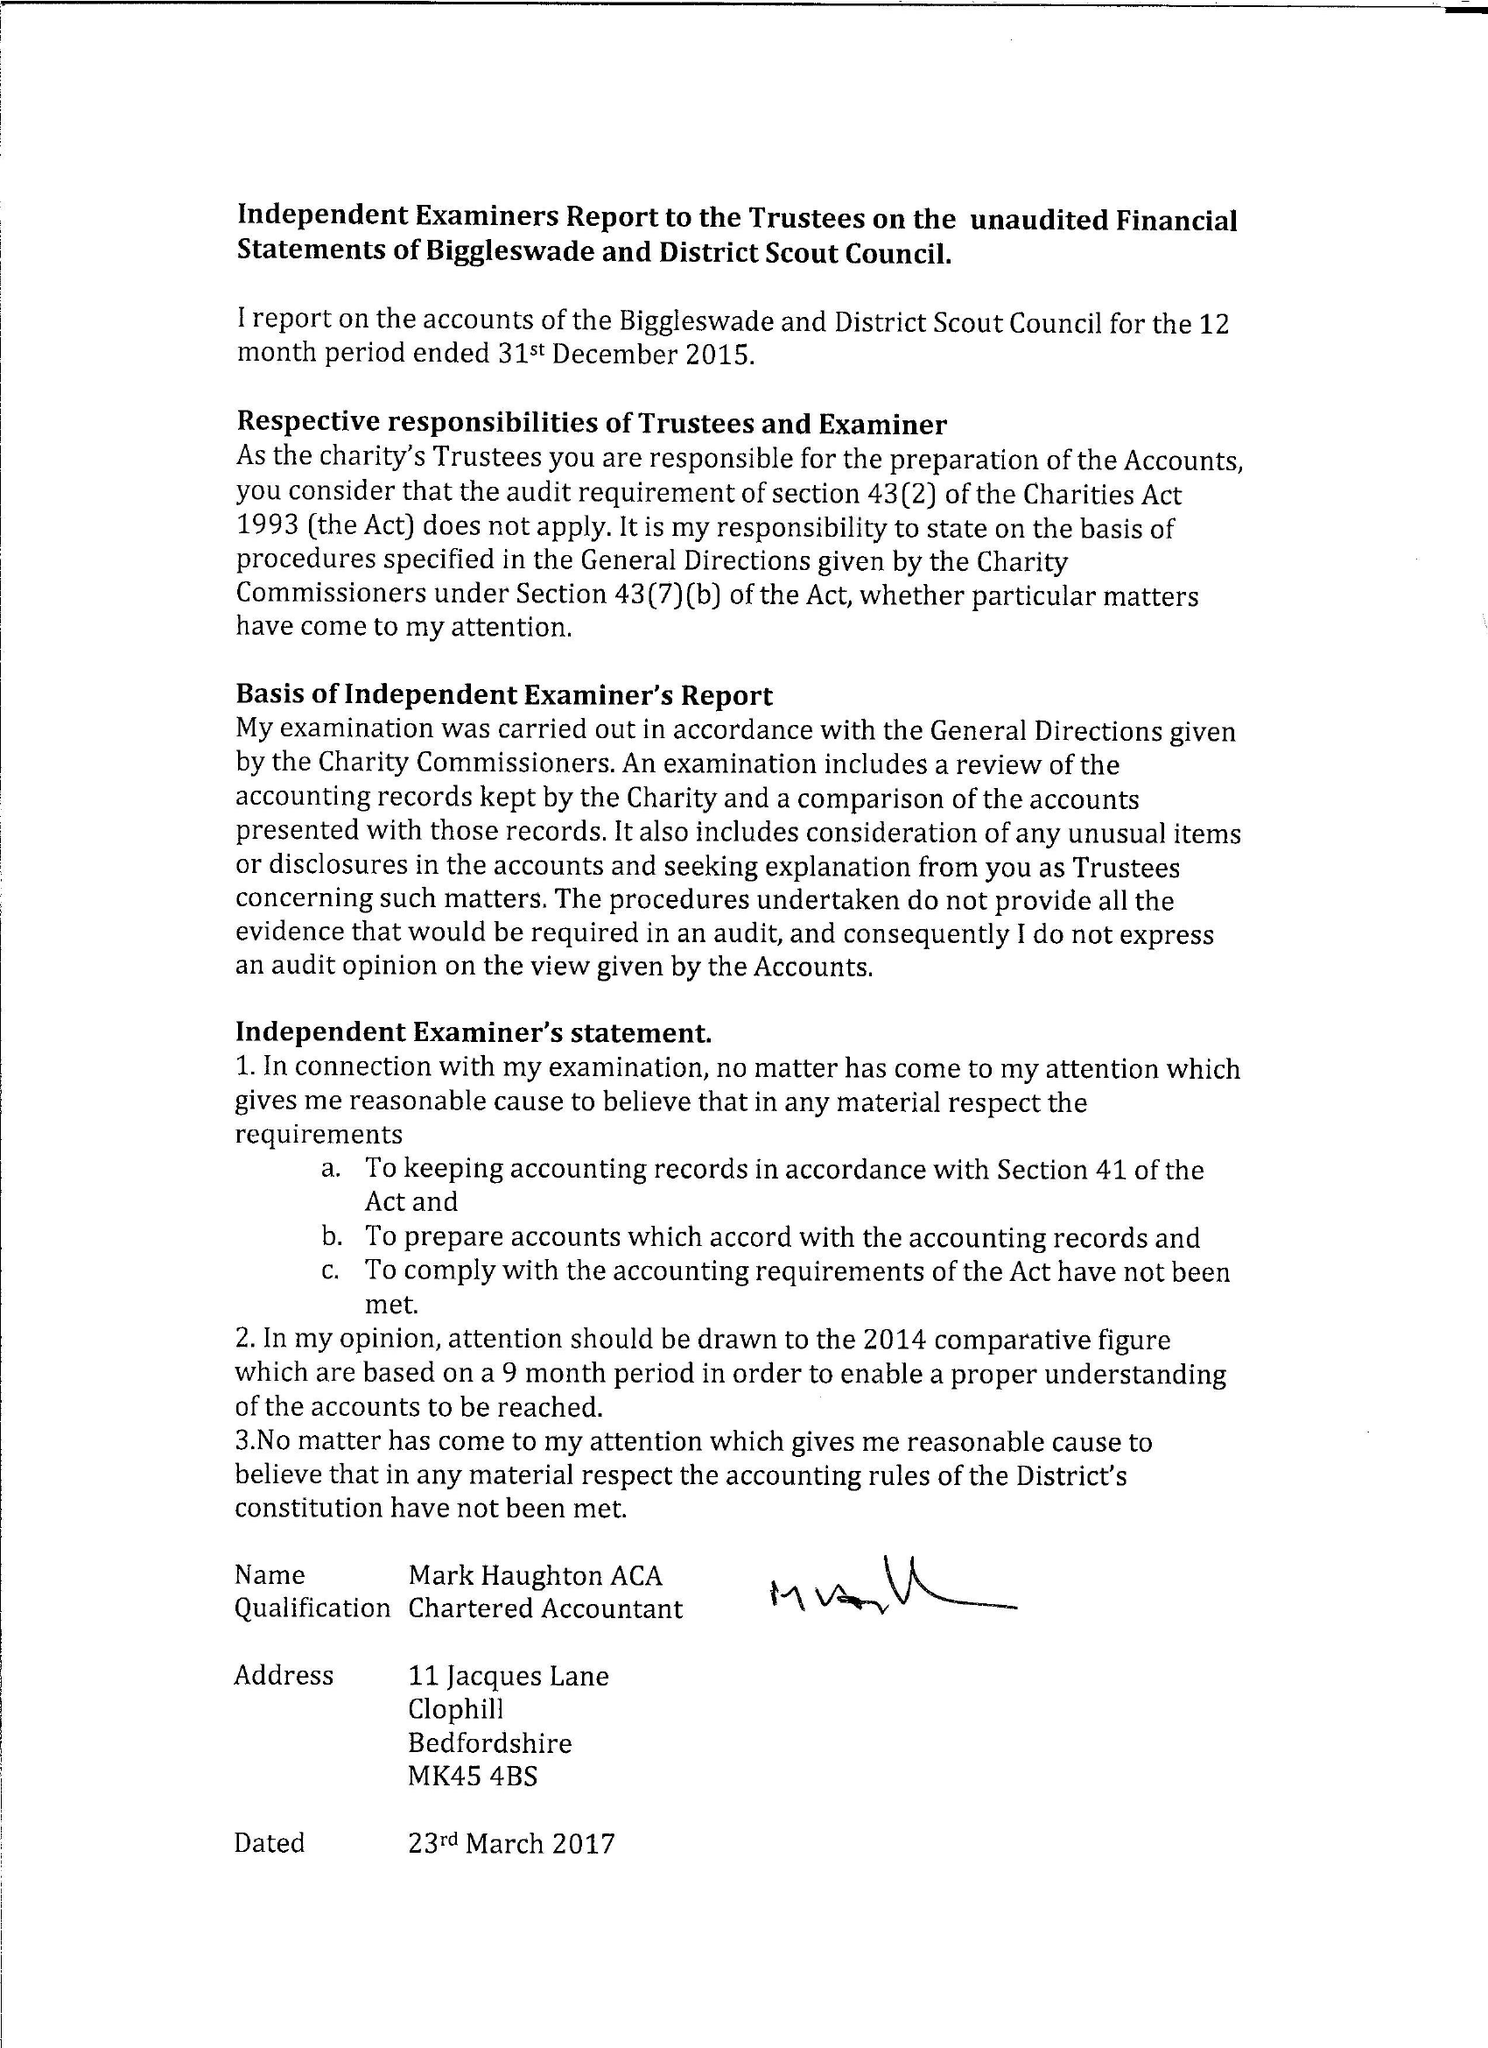What is the value for the address__post_town?
Answer the question using a single word or phrase. BIGGLESWADE 